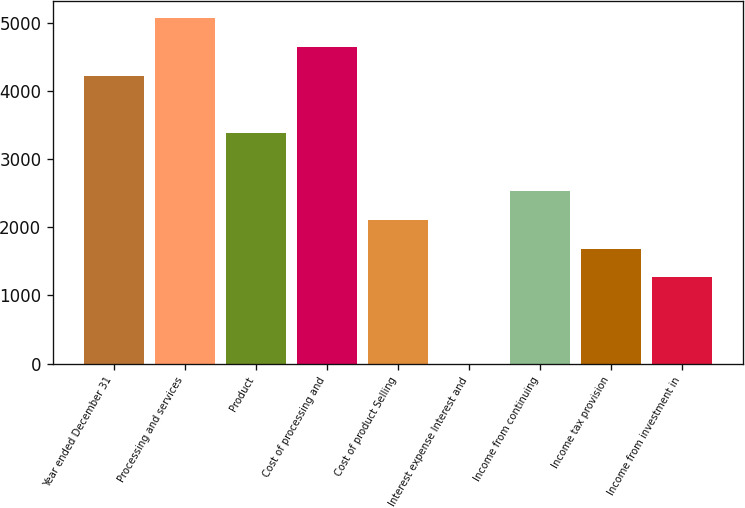Convert chart. <chart><loc_0><loc_0><loc_500><loc_500><bar_chart><fcel>Year ended December 31<fcel>Processing and services<fcel>Product<fcel>Cost of processing and<fcel>Cost of product Selling<fcel>Interest expense Interest and<fcel>Income from continuing<fcel>Income tax provision<fcel>Income from investment in<nl><fcel>4219<fcel>5062.6<fcel>3375.4<fcel>4640.8<fcel>2110<fcel>1<fcel>2531.8<fcel>1688.2<fcel>1266.4<nl></chart> 